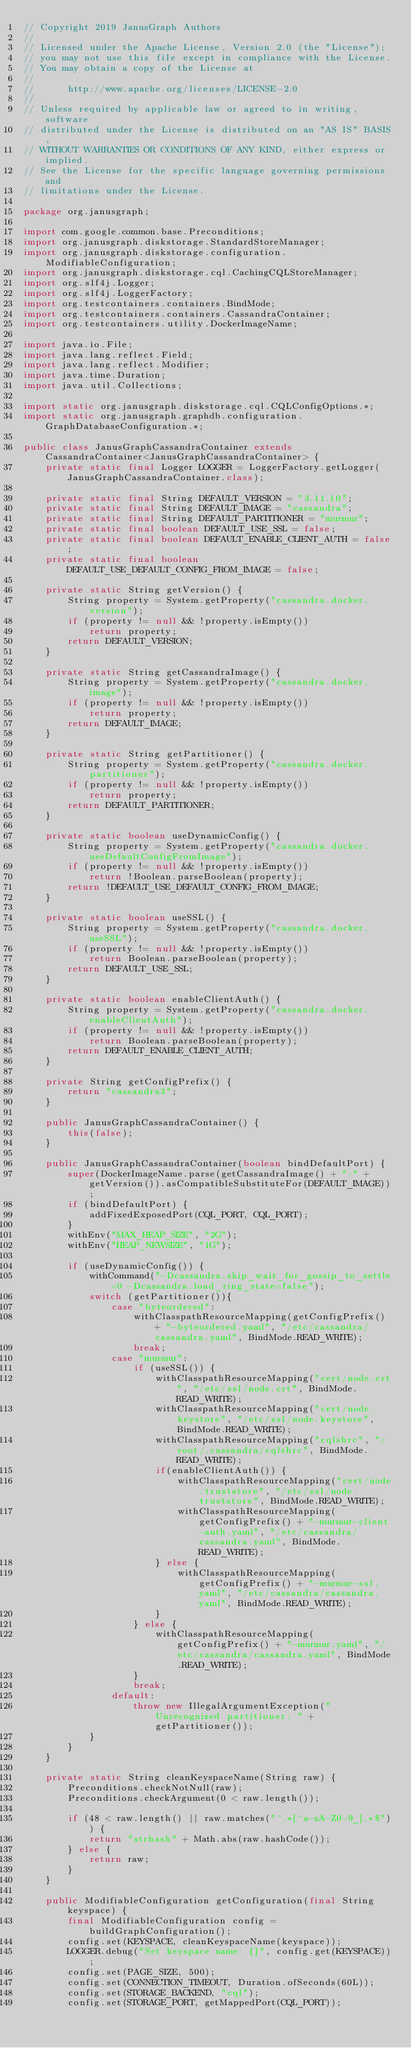<code> <loc_0><loc_0><loc_500><loc_500><_Java_>// Copyright 2019 JanusGraph Authors
//
// Licensed under the Apache License, Version 2.0 (the "License");
// you may not use this file except in compliance with the License.
// You may obtain a copy of the License at
//
//      http://www.apache.org/licenses/LICENSE-2.0
//
// Unless required by applicable law or agreed to in writing, software
// distributed under the License is distributed on an "AS IS" BASIS,
// WITHOUT WARRANTIES OR CONDITIONS OF ANY KIND, either express or implied.
// See the License for the specific language governing permissions and
// limitations under the License.

package org.janusgraph;

import com.google.common.base.Preconditions;
import org.janusgraph.diskstorage.StandardStoreManager;
import org.janusgraph.diskstorage.configuration.ModifiableConfiguration;
import org.janusgraph.diskstorage.cql.CachingCQLStoreManager;
import org.slf4j.Logger;
import org.slf4j.LoggerFactory;
import org.testcontainers.containers.BindMode;
import org.testcontainers.containers.CassandraContainer;
import org.testcontainers.utility.DockerImageName;

import java.io.File;
import java.lang.reflect.Field;
import java.lang.reflect.Modifier;
import java.time.Duration;
import java.util.Collections;

import static org.janusgraph.diskstorage.cql.CQLConfigOptions.*;
import static org.janusgraph.graphdb.configuration.GraphDatabaseConfiguration.*;

public class JanusGraphCassandraContainer extends CassandraContainer<JanusGraphCassandraContainer> {
    private static final Logger LOGGER = LoggerFactory.getLogger(JanusGraphCassandraContainer.class);

    private static final String DEFAULT_VERSION = "3.11.10";
    private static final String DEFAULT_IMAGE = "cassandra";
    private static final String DEFAULT_PARTITIONER = "murmur";
    private static final boolean DEFAULT_USE_SSL = false;
    private static final boolean DEFAULT_ENABLE_CLIENT_AUTH = false;
    private static final boolean DEFAULT_USE_DEFAULT_CONFIG_FROM_IMAGE = false;

    private static String getVersion() {
        String property = System.getProperty("cassandra.docker.version");
        if (property != null && !property.isEmpty())
            return property;
        return DEFAULT_VERSION;
    }

    private static String getCassandraImage() {
        String property = System.getProperty("cassandra.docker.image");
        if (property != null && !property.isEmpty())
            return property;
        return DEFAULT_IMAGE;
    }

    private static String getPartitioner() {
        String property = System.getProperty("cassandra.docker.partitioner");
        if (property != null && !property.isEmpty())
            return property;
        return DEFAULT_PARTITIONER;
    }

    private static boolean useDynamicConfig() {
        String property = System.getProperty("cassandra.docker.useDefaultConfigFromImage");
        if (property != null && !property.isEmpty())
            return !Boolean.parseBoolean(property);
        return !DEFAULT_USE_DEFAULT_CONFIG_FROM_IMAGE;
    }

    private static boolean useSSL() {
        String property = System.getProperty("cassandra.docker.useSSL");
        if (property != null && !property.isEmpty())
            return Boolean.parseBoolean(property);
        return DEFAULT_USE_SSL;
    }

    private static boolean enableClientAuth() {
        String property = System.getProperty("cassandra.docker.enableClientAuth");
        if (property != null && !property.isEmpty())
            return Boolean.parseBoolean(property);
        return DEFAULT_ENABLE_CLIENT_AUTH;
    }

    private String getConfigPrefix() {
        return "cassandra3";
    }

    public JanusGraphCassandraContainer() {
        this(false);
    }

    public JanusGraphCassandraContainer(boolean bindDefaultPort) {
        super(DockerImageName.parse(getCassandraImage() + ":" + getVersion()).asCompatibleSubstituteFor(DEFAULT_IMAGE));
        if (bindDefaultPort) {
            addFixedExposedPort(CQL_PORT, CQL_PORT);
        }
        withEnv("MAX_HEAP_SIZE", "2G");
        withEnv("HEAP_NEWSIZE", "1G");

        if (useDynamicConfig()) {
            withCommand("-Dcassandra.skip_wait_for_gossip_to_settle=0 -Dcassandra.load_ring_state=false");
            switch (getPartitioner()){
                case "byteordered":
                    withClasspathResourceMapping(getConfigPrefix() + "-byteordered.yaml", "/etc/cassandra/cassandra.yaml", BindMode.READ_WRITE);
                    break;
                case "murmur":
                    if (useSSL()) {
                        withClasspathResourceMapping("cert/node.crt", "/etc/ssl/node.crt", BindMode.READ_WRITE);
                        withClasspathResourceMapping("cert/node.keystore", "/etc/ssl/node.keystore", BindMode.READ_WRITE);
                        withClasspathResourceMapping("cqlshrc", "/root/.cassandra/cqlshrc", BindMode.READ_WRITE);
                        if(enableClientAuth()) {
                            withClasspathResourceMapping("cert/node.truststore", "/etc/ssl/node.truststore", BindMode.READ_WRITE);
                            withClasspathResourceMapping(getConfigPrefix() + "-murmur-client-auth.yaml", "/etc/cassandra/cassandra.yaml", BindMode.READ_WRITE);
                        } else {
                            withClasspathResourceMapping(getConfigPrefix() + "-murmur-ssl.yaml", "/etc/cassandra/cassandra.yaml", BindMode.READ_WRITE);
                        }
                    } else {
                        withClasspathResourceMapping(getConfigPrefix() + "-murmur.yaml", "/etc/cassandra/cassandra.yaml", BindMode.READ_WRITE);
                    }
                    break;
                default:
                    throw new IllegalArgumentException("Unrecognized partitioner: " + getPartitioner());
            }
        }
    }

    private static String cleanKeyspaceName(String raw) {
        Preconditions.checkNotNull(raw);
        Preconditions.checkArgument(0 < raw.length());

        if (48 < raw.length() || raw.matches("^.*[^a-zA-Z0-9_].*$")) {
            return "strhash" + Math.abs(raw.hashCode());
        } else {
            return raw;
        }
    }

    public ModifiableConfiguration getConfiguration(final String keyspace) {
        final ModifiableConfiguration config = buildGraphConfiguration();
        config.set(KEYSPACE, cleanKeyspaceName(keyspace));
        LOGGER.debug("Set keyspace name: {}", config.get(KEYSPACE));
        config.set(PAGE_SIZE, 500);
        config.set(CONNECTION_TIMEOUT, Duration.ofSeconds(60L));
        config.set(STORAGE_BACKEND, "cql");
        config.set(STORAGE_PORT, getMappedPort(CQL_PORT));</code> 